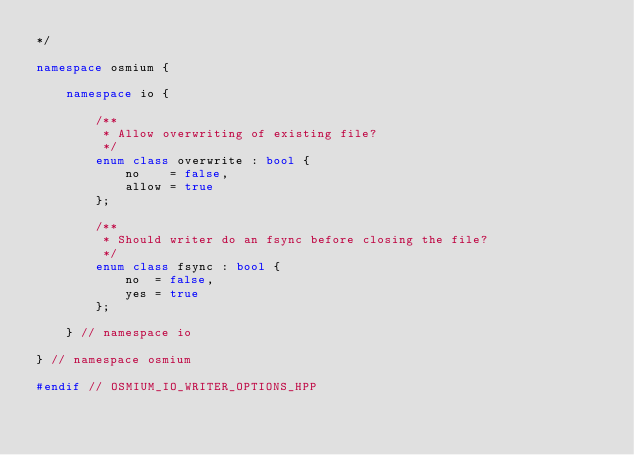Convert code to text. <code><loc_0><loc_0><loc_500><loc_500><_C++_>*/

namespace osmium {

    namespace io {

        /**
         * Allow overwriting of existing file?
         */
        enum class overwrite : bool {
            no    = false,
            allow = true
        };

        /**
         * Should writer do an fsync before closing the file?
         */
        enum class fsync : bool {
            no  = false,
            yes = true
        };

    } // namespace io

} // namespace osmium

#endif // OSMIUM_IO_WRITER_OPTIONS_HPP
</code> 